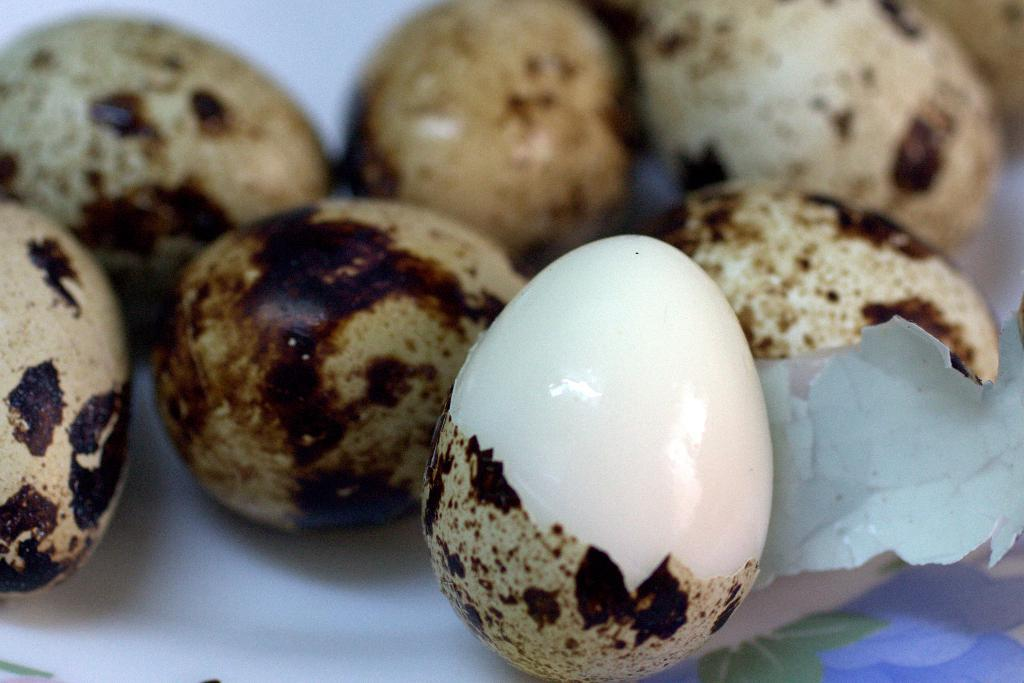What type of food is present in the image? There are boiled eggs in a plate in the image. How are the boiled eggs arranged or presented in the image? The boiled eggs are in a plate in the image. What type of effect does the airport have on the boiled eggs in the image? There is no airport present in the image, so it cannot have any effect on the boiled eggs. 